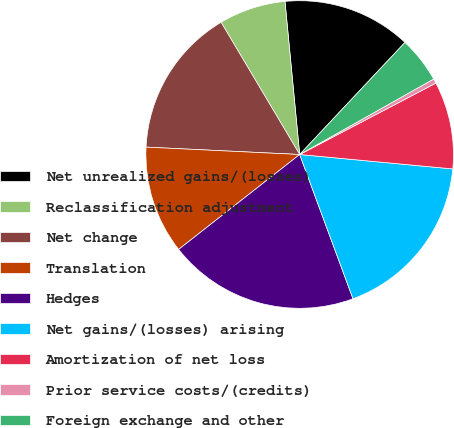Convert chart to OTSL. <chart><loc_0><loc_0><loc_500><loc_500><pie_chart><fcel>Net unrealized gains/(losses)<fcel>Reclassification adjustment<fcel>Net change<fcel>Translation<fcel>Hedges<fcel>Net gains/(losses) arising<fcel>Amortization of net loss<fcel>Prior service costs/(credits)<fcel>Foreign exchange and other<nl><fcel>13.53%<fcel>7.01%<fcel>15.7%<fcel>11.35%<fcel>20.05%<fcel>17.87%<fcel>9.18%<fcel>0.48%<fcel>4.83%<nl></chart> 